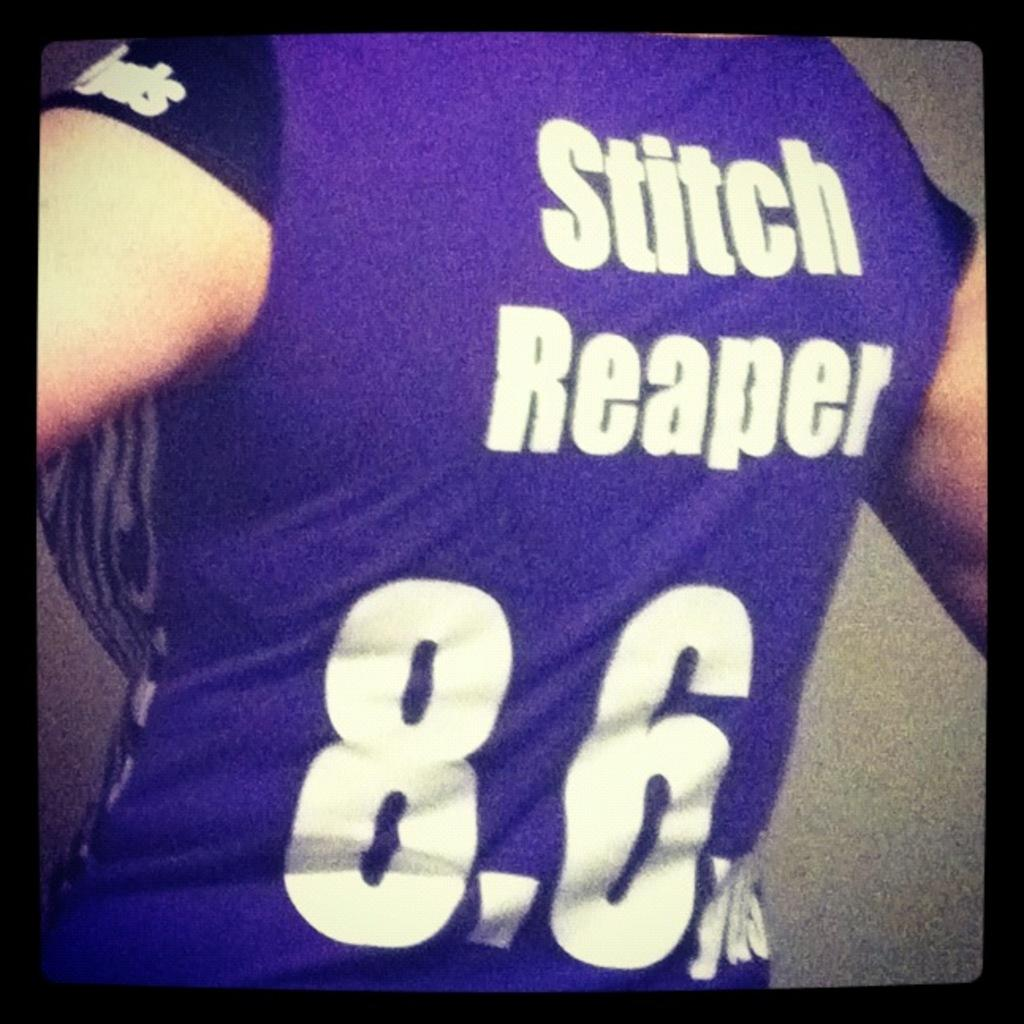Provide a one-sentence caption for the provided image. A person wears a blue top with Stitch Reaper on the back. 